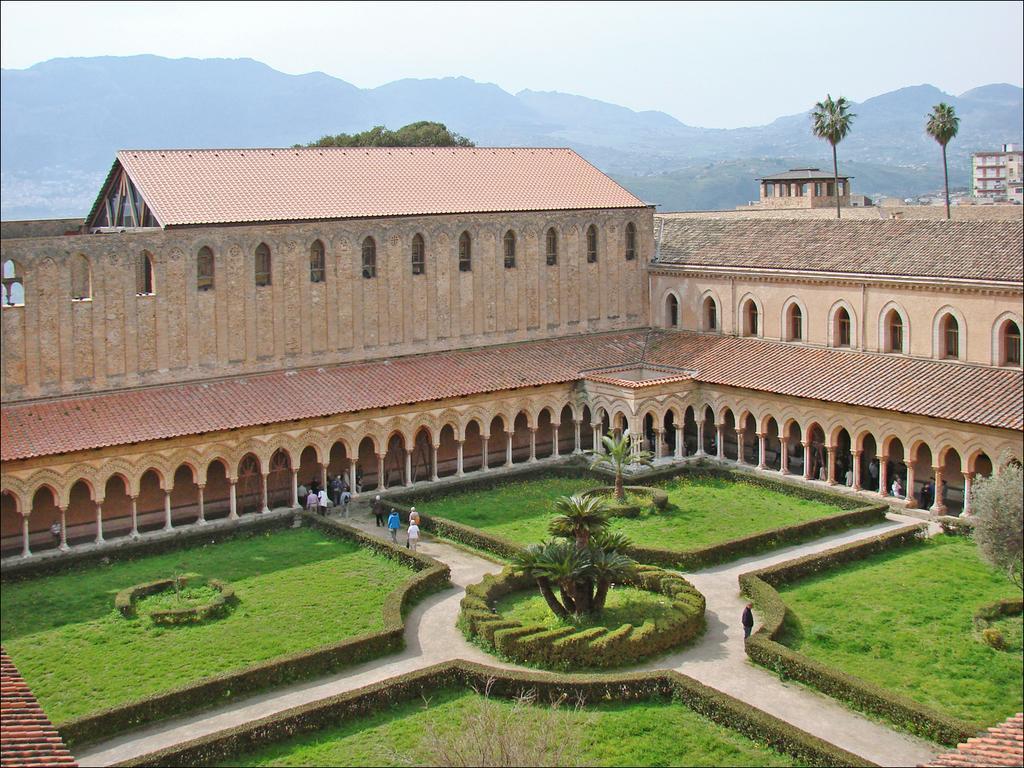In one or two sentences, can you explain what this image depicts? In the center of the image we can see a building with poles and windows and a roof. In the foreground we can see group of persons standing on the ground and plants. In the background, we can see trees and the sky. 